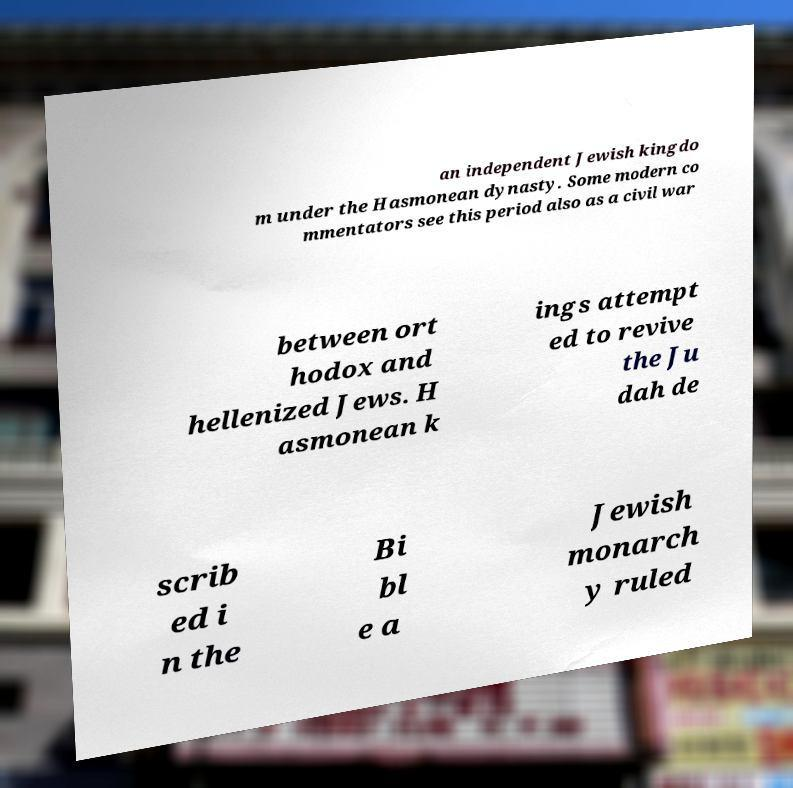Please read and relay the text visible in this image. What does it say? an independent Jewish kingdo m under the Hasmonean dynasty. Some modern co mmentators see this period also as a civil war between ort hodox and hellenized Jews. H asmonean k ings attempt ed to revive the Ju dah de scrib ed i n the Bi bl e a Jewish monarch y ruled 